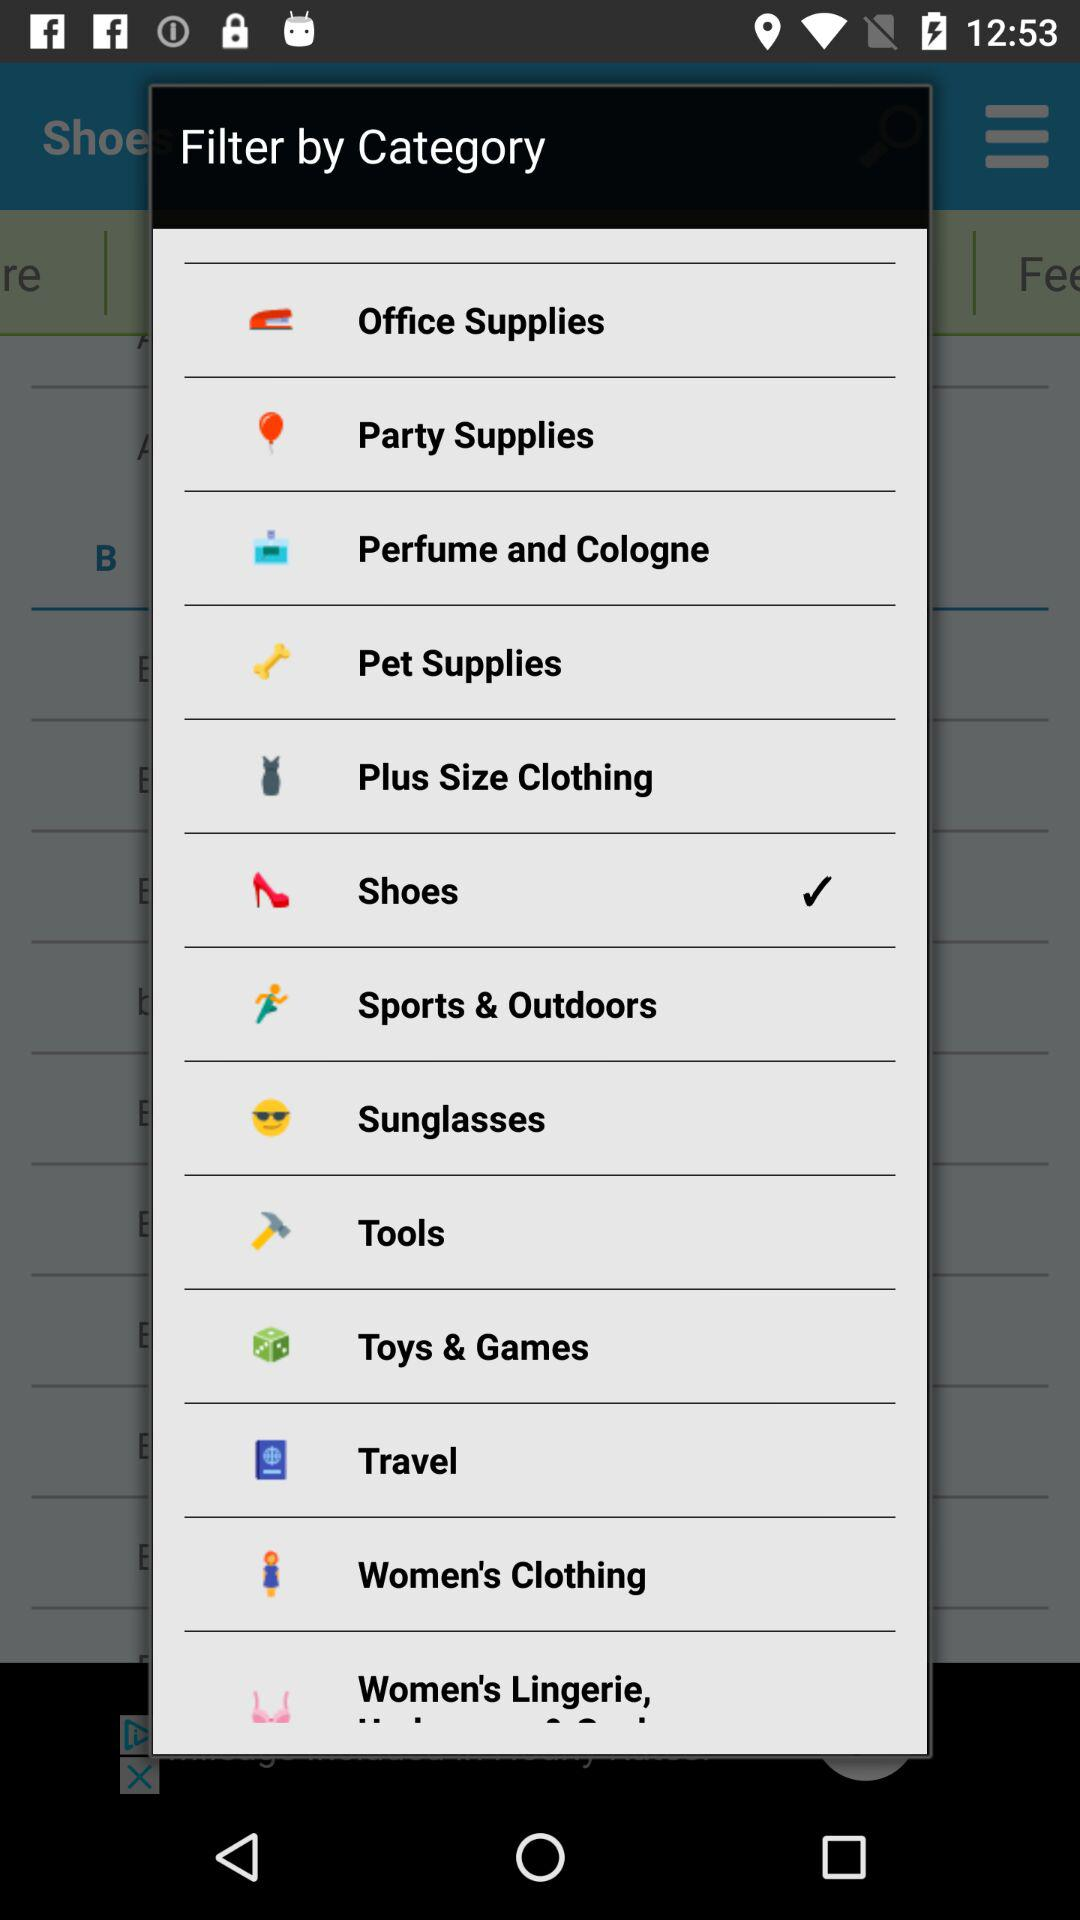Which category is selected? The selected category is "Shoes". 